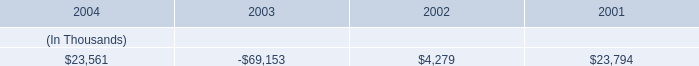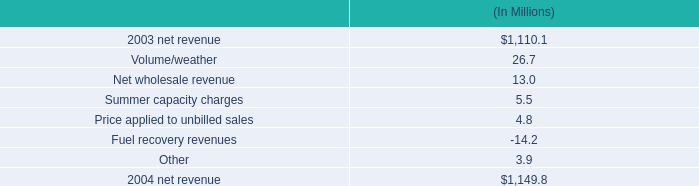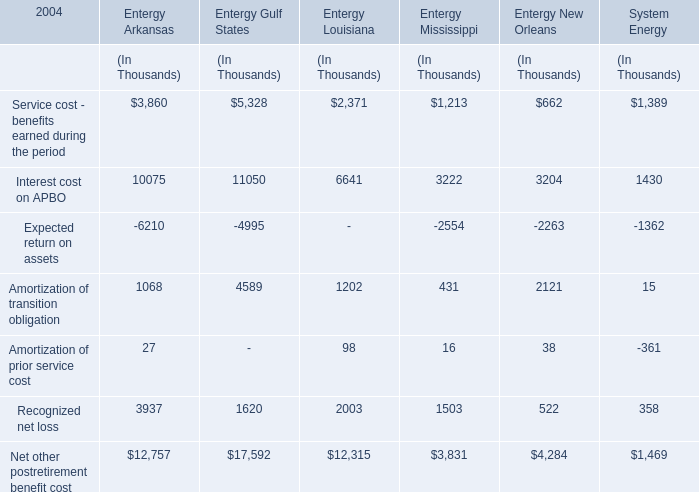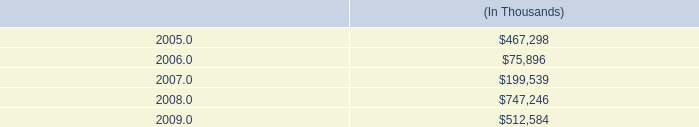What is the ratio of all Entergy Gulf States that are smaller than 7000 to the sum of Entergy Gulf States , in 2004? 
Computations: ((((5328 - 4995) + 4589) + 1620) / 17592)
Answer: 0.37187. 